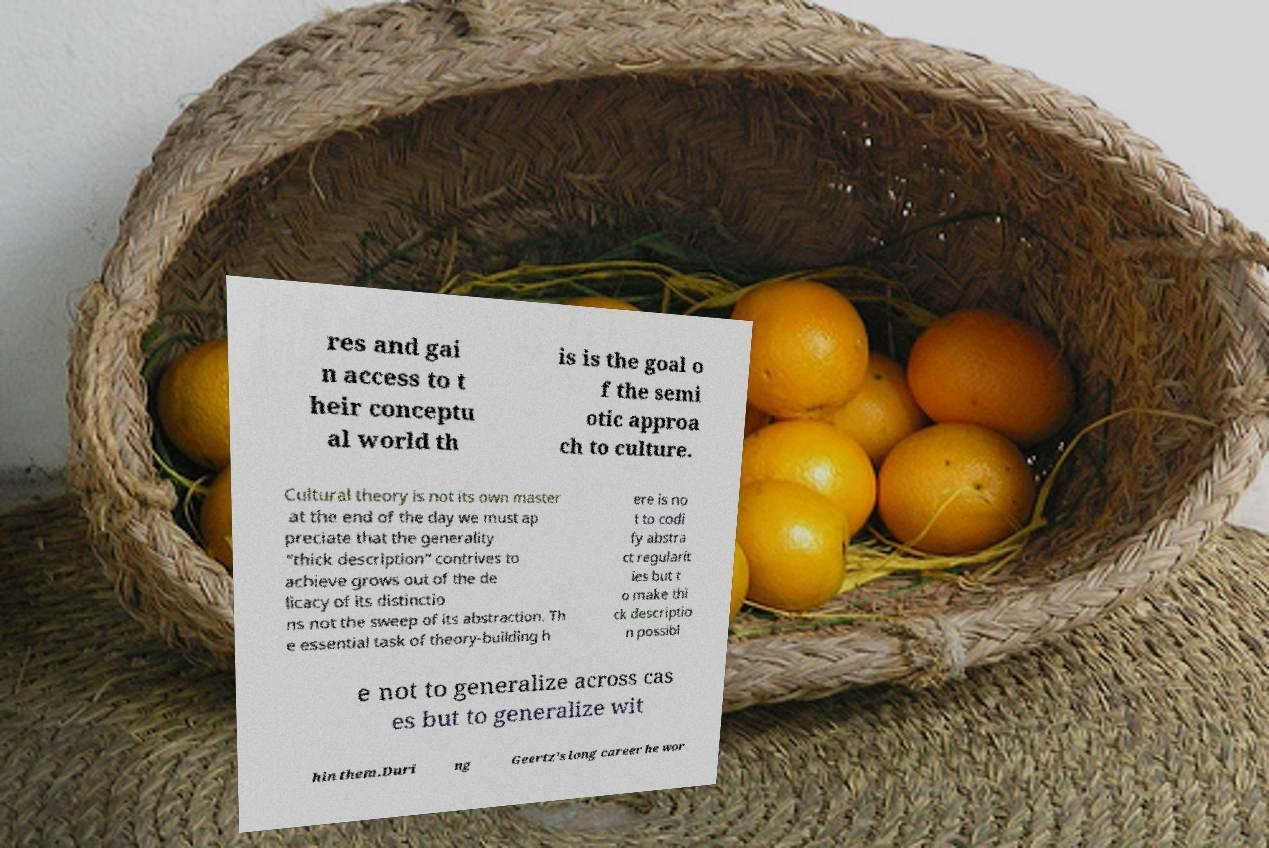Please read and relay the text visible in this image. What does it say? res and gai n access to t heir conceptu al world th is is the goal o f the semi otic approa ch to culture. Cultural theory is not its own master at the end of the day we must ap preciate that the generality “thick description” contrives to achieve grows out of the de licacy of its distinctio ns not the sweep of its abstraction. Th e essential task of theory-building h ere is no t to codi fy abstra ct regularit ies but t o make thi ck descriptio n possibl e not to generalize across cas es but to generalize wit hin them.Duri ng Geertz's long career he wor 